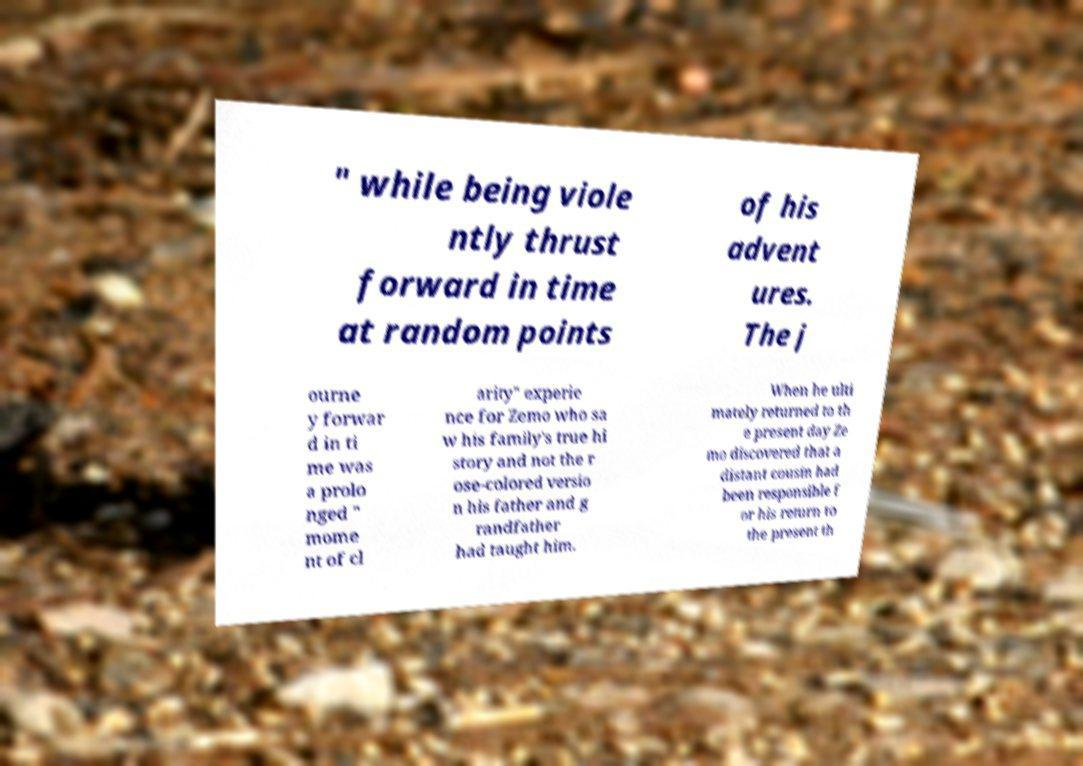Please identify and transcribe the text found in this image. " while being viole ntly thrust forward in time at random points of his advent ures. The j ourne y forwar d in ti me was a prolo nged " mome nt of cl arity" experie nce for Zemo who sa w his family's true hi story and not the r ose-colored versio n his father and g randfather had taught him. When he ulti mately returned to th e present day Ze mo discovered that a distant cousin had been responsible f or his return to the present th 